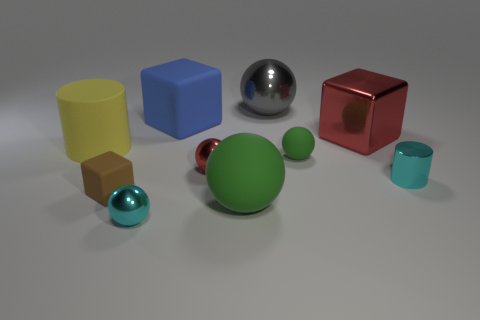There is a rubber cube that is left of the tiny sphere that is in front of the big thing that is in front of the rubber cylinder; what color is it?
Your answer should be compact. Brown. There is a sphere that is behind the tiny red metallic ball and in front of the gray metal object; how big is it?
Your answer should be compact. Small. What number of other things are the same shape as the small green rubber thing?
Give a very brief answer. 4. How many cubes are either big yellow things or big gray shiny objects?
Ensure brevity in your answer.  0. Are there any cyan metallic things that are on the left side of the small cyan metallic thing on the right side of the shiny ball in front of the tiny cyan metal cylinder?
Provide a succinct answer. Yes. The other big metallic object that is the same shape as the big blue object is what color?
Provide a succinct answer. Red. What number of green objects are small matte cubes or tiny balls?
Give a very brief answer. 1. There is a cyan thing that is on the right side of the large ball behind the big metallic cube; what is its material?
Provide a short and direct response. Metal. Is the shape of the tiny brown object the same as the big blue rubber object?
Offer a terse response. Yes. There is a shiny cylinder that is the same size as the red sphere; what color is it?
Provide a short and direct response. Cyan. 